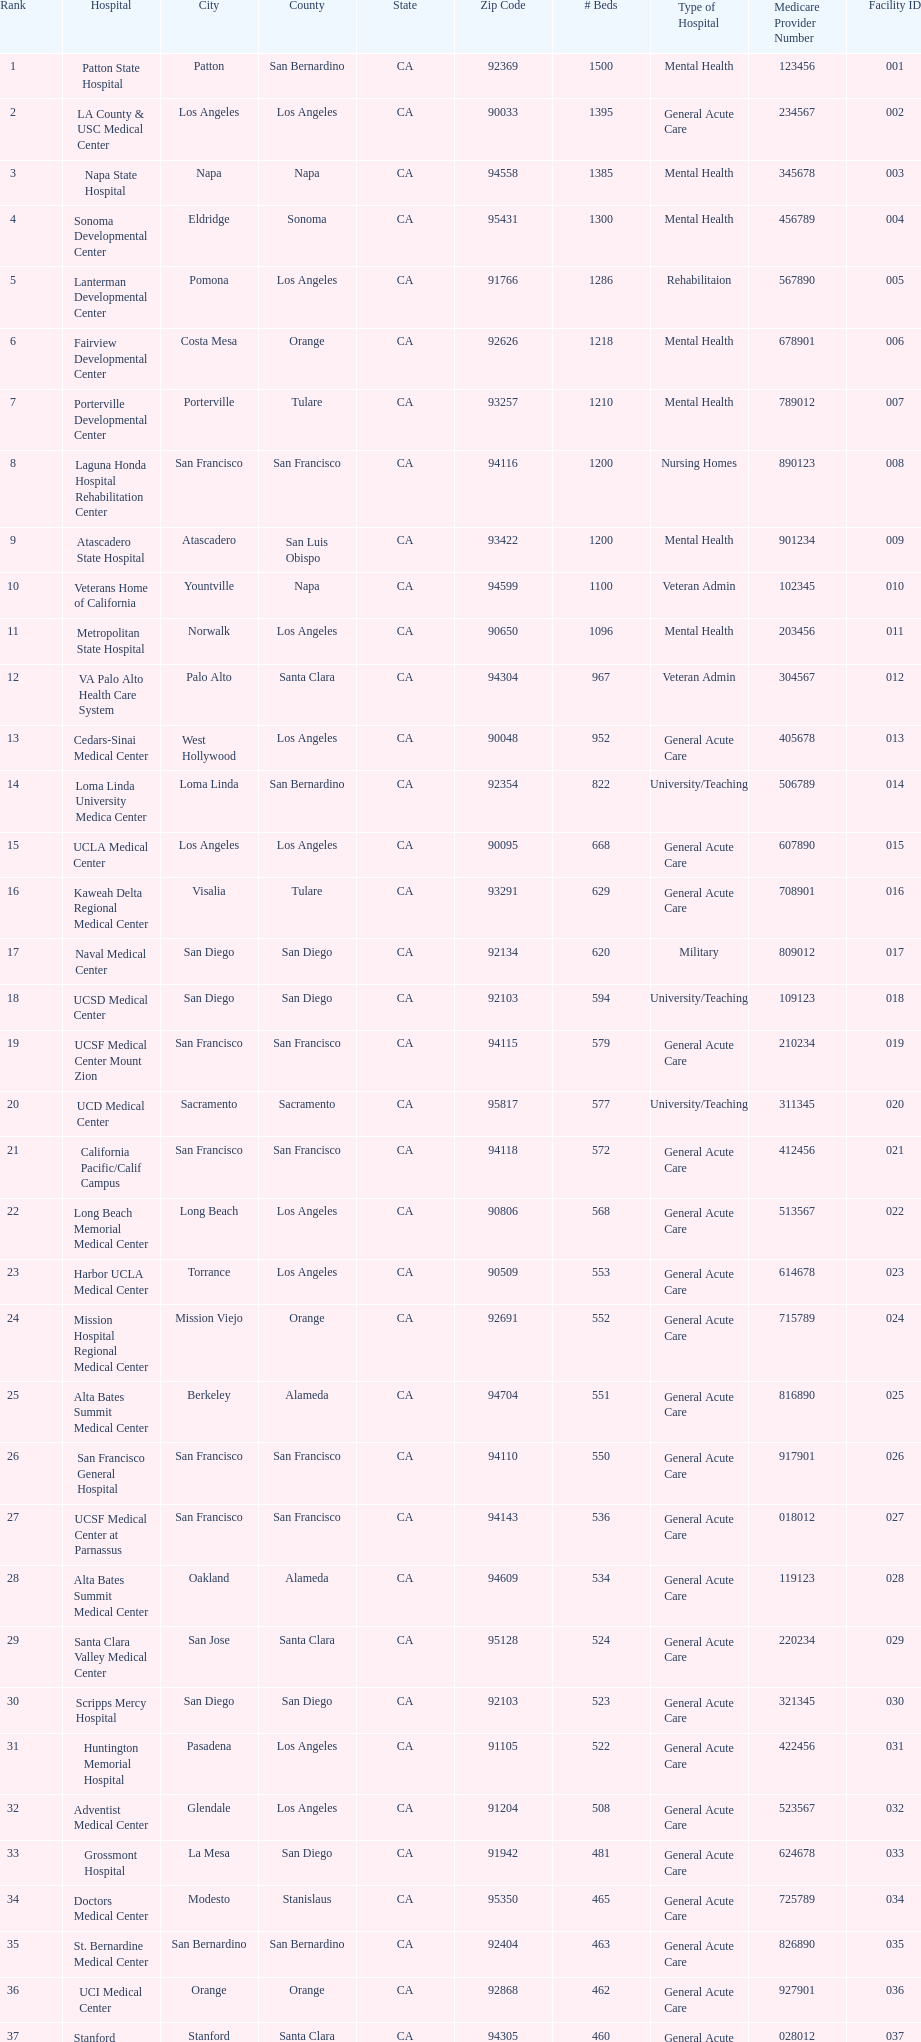How many more general acute care hospitals are there in california than rehabilitation hospitals? 33. 